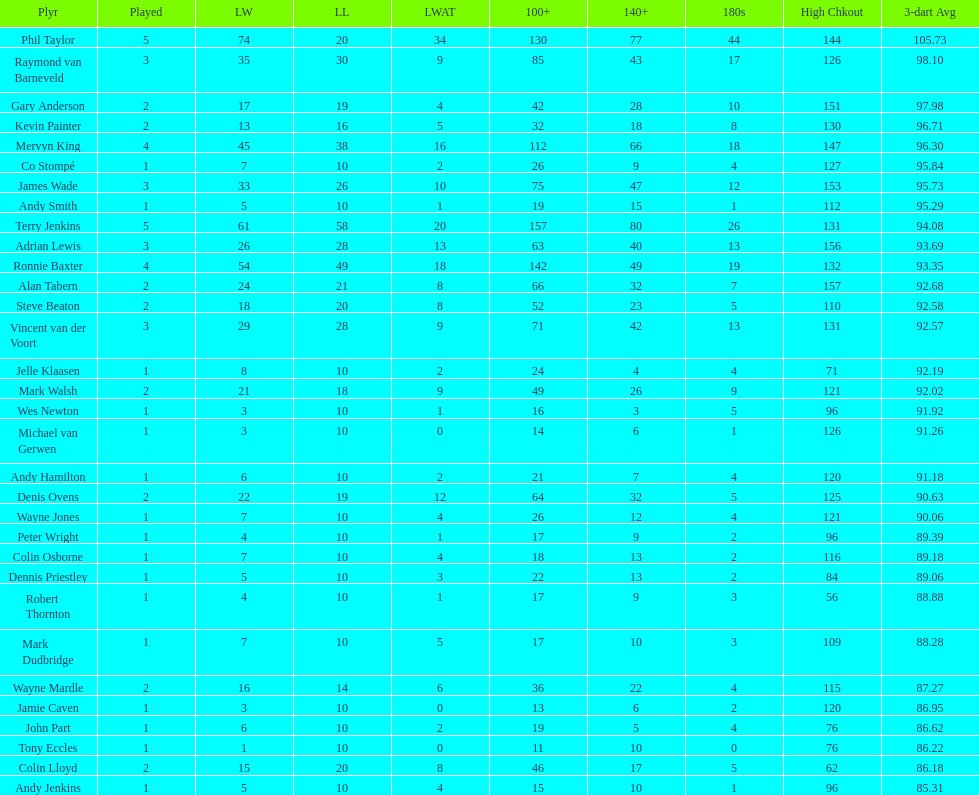Mark walsh's average is above/below 93? Below. 